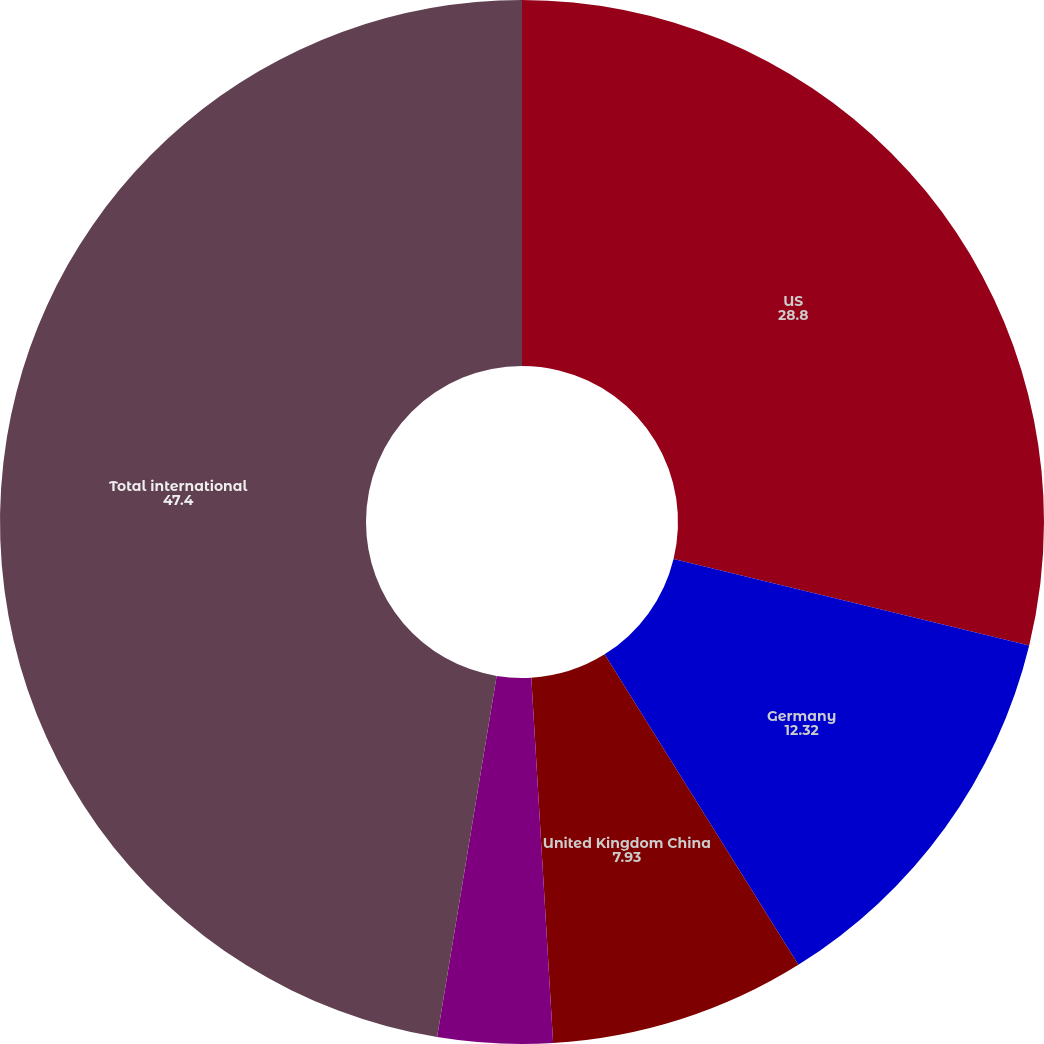Convert chart to OTSL. <chart><loc_0><loc_0><loc_500><loc_500><pie_chart><fcel>US<fcel>Germany<fcel>United Kingdom China<fcel>France Italy<fcel>Total international<nl><fcel>28.8%<fcel>12.32%<fcel>7.93%<fcel>3.55%<fcel>47.4%<nl></chart> 